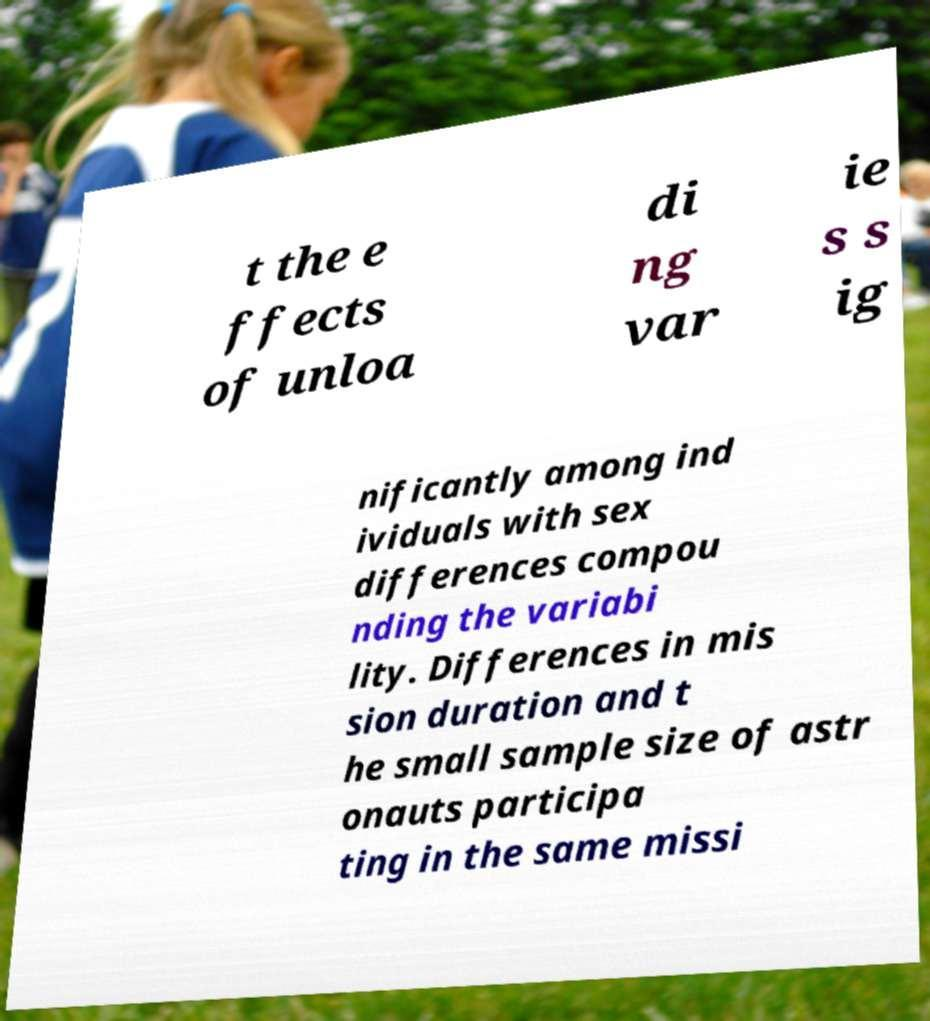For documentation purposes, I need the text within this image transcribed. Could you provide that? t the e ffects of unloa di ng var ie s s ig nificantly among ind ividuals with sex differences compou nding the variabi lity. Differences in mis sion duration and t he small sample size of astr onauts participa ting in the same missi 